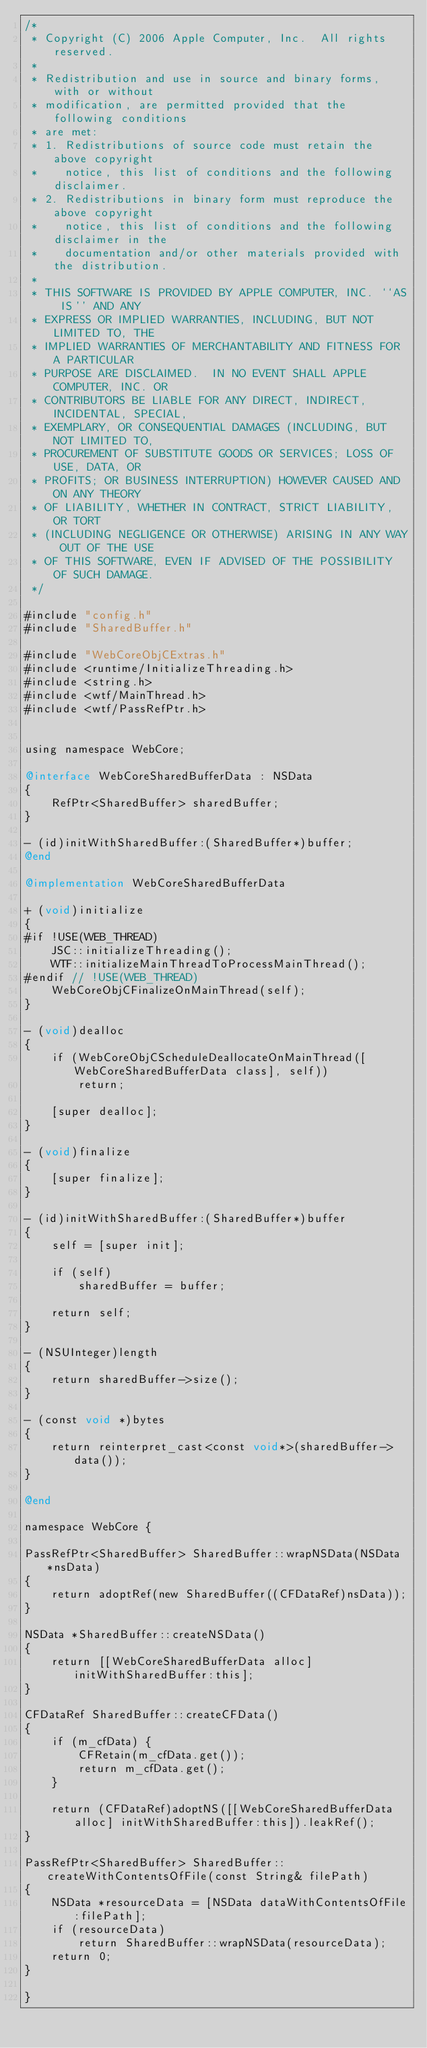Convert code to text. <code><loc_0><loc_0><loc_500><loc_500><_ObjectiveC_>/*
 * Copyright (C) 2006 Apple Computer, Inc.  All rights reserved.
 *
 * Redistribution and use in source and binary forms, with or without
 * modification, are permitted provided that the following conditions
 * are met:
 * 1. Redistributions of source code must retain the above copyright
 *    notice, this list of conditions and the following disclaimer.
 * 2. Redistributions in binary form must reproduce the above copyright
 *    notice, this list of conditions and the following disclaimer in the
 *    documentation and/or other materials provided with the distribution.
 *
 * THIS SOFTWARE IS PROVIDED BY APPLE COMPUTER, INC. ``AS IS'' AND ANY
 * EXPRESS OR IMPLIED WARRANTIES, INCLUDING, BUT NOT LIMITED TO, THE
 * IMPLIED WARRANTIES OF MERCHANTABILITY AND FITNESS FOR A PARTICULAR
 * PURPOSE ARE DISCLAIMED.  IN NO EVENT SHALL APPLE COMPUTER, INC. OR
 * CONTRIBUTORS BE LIABLE FOR ANY DIRECT, INDIRECT, INCIDENTAL, SPECIAL,
 * EXEMPLARY, OR CONSEQUENTIAL DAMAGES (INCLUDING, BUT NOT LIMITED TO,
 * PROCUREMENT OF SUBSTITUTE GOODS OR SERVICES; LOSS OF USE, DATA, OR
 * PROFITS; OR BUSINESS INTERRUPTION) HOWEVER CAUSED AND ON ANY THEORY
 * OF LIABILITY, WHETHER IN CONTRACT, STRICT LIABILITY, OR TORT
 * (INCLUDING NEGLIGENCE OR OTHERWISE) ARISING IN ANY WAY OUT OF THE USE
 * OF THIS SOFTWARE, EVEN IF ADVISED OF THE POSSIBILITY OF SUCH DAMAGE. 
 */

#include "config.h"
#include "SharedBuffer.h"

#include "WebCoreObjCExtras.h"
#include <runtime/InitializeThreading.h>
#include <string.h>
#include <wtf/MainThread.h>
#include <wtf/PassRefPtr.h>


using namespace WebCore;

@interface WebCoreSharedBufferData : NSData
{
    RefPtr<SharedBuffer> sharedBuffer;
}

- (id)initWithSharedBuffer:(SharedBuffer*)buffer;
@end

@implementation WebCoreSharedBufferData

+ (void)initialize
{
#if !USE(WEB_THREAD)
    JSC::initializeThreading();
    WTF::initializeMainThreadToProcessMainThread();
#endif // !USE(WEB_THREAD)
    WebCoreObjCFinalizeOnMainThread(self);
}

- (void)dealloc
{
    if (WebCoreObjCScheduleDeallocateOnMainThread([WebCoreSharedBufferData class], self))
        return;
    
    [super dealloc];
}

- (void)finalize
{
    [super finalize];
}

- (id)initWithSharedBuffer:(SharedBuffer*)buffer
{
    self = [super init];
    
    if (self)
        sharedBuffer = buffer;
    
    return self;
}

- (NSUInteger)length
{
    return sharedBuffer->size();
}

- (const void *)bytes
{
    return reinterpret_cast<const void*>(sharedBuffer->data());
}

@end

namespace WebCore {

PassRefPtr<SharedBuffer> SharedBuffer::wrapNSData(NSData *nsData)
{
    return adoptRef(new SharedBuffer((CFDataRef)nsData));
}

NSData *SharedBuffer::createNSData()
{    
    return [[WebCoreSharedBufferData alloc] initWithSharedBuffer:this];
}

CFDataRef SharedBuffer::createCFData()
{
    if (m_cfData) {
        CFRetain(m_cfData.get());
        return m_cfData.get();
    }
    
    return (CFDataRef)adoptNS([[WebCoreSharedBufferData alloc] initWithSharedBuffer:this]).leakRef();
}

PassRefPtr<SharedBuffer> SharedBuffer::createWithContentsOfFile(const String& filePath)
{
    NSData *resourceData = [NSData dataWithContentsOfFile:filePath];
    if (resourceData) 
        return SharedBuffer::wrapNSData(resourceData);
    return 0;
}

}
</code> 